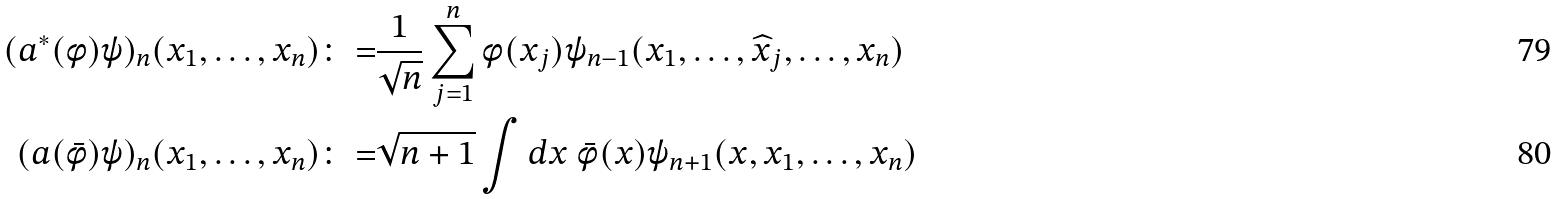<formula> <loc_0><loc_0><loc_500><loc_500>( a ^ { \ast } ( \phi ) \psi ) _ { n } ( x _ { 1 } , \dots , x _ { n } ) \colon = & \frac { 1 } { \sqrt { n } } \sum ^ { n } _ { j = 1 } \phi ( x _ { j } ) \psi _ { n - 1 } ( x _ { 1 } , \dots , \widehat { x } _ { j } , \dots , x _ { n } ) \\ ( a ( \bar { \phi } ) \psi ) _ { n } ( x _ { 1 } , \dots , x _ { n } ) \colon = & \sqrt { n + 1 } \int d x \ \bar { \phi } ( x ) \psi _ { n + 1 } ( x , x _ { 1 } , \dots , x _ { n } )</formula> 